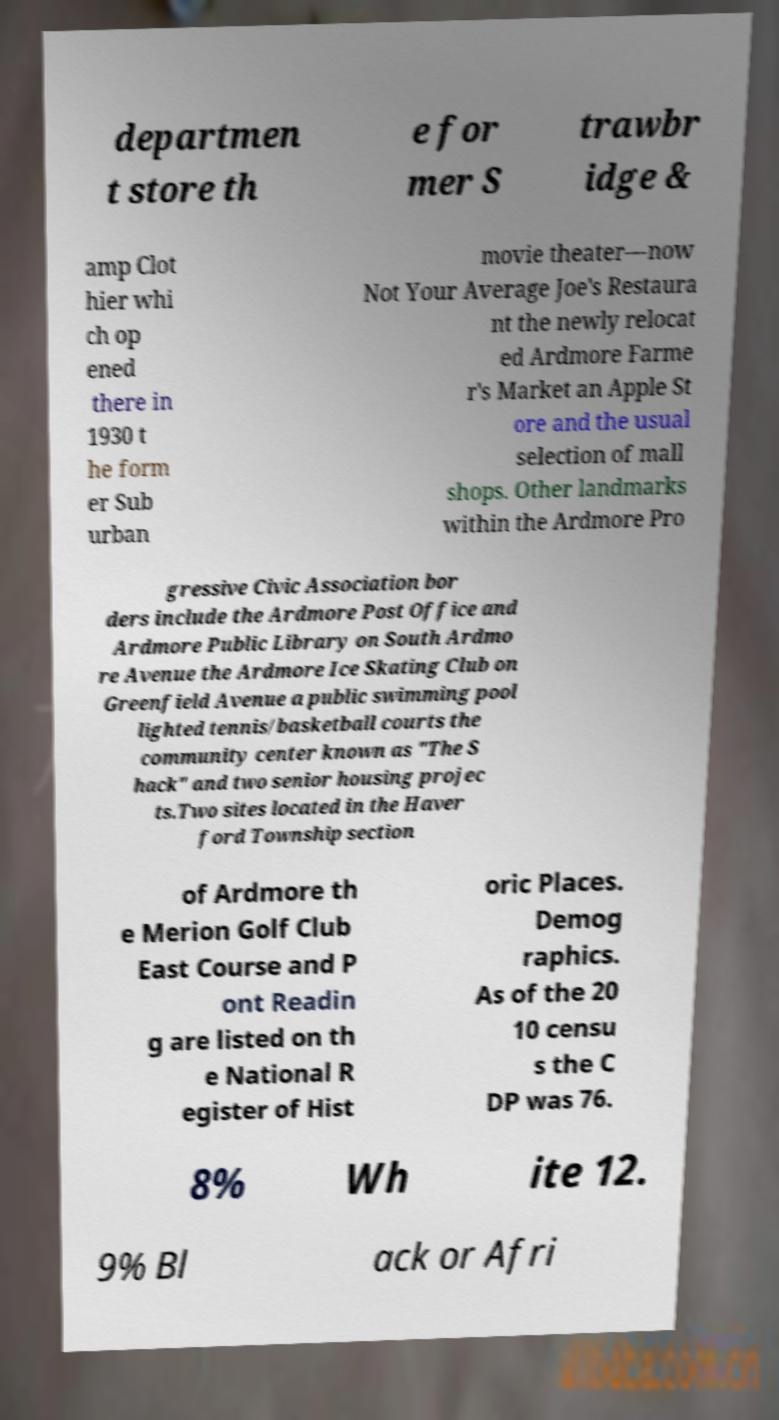There's text embedded in this image that I need extracted. Can you transcribe it verbatim? departmen t store th e for mer S trawbr idge & amp Clot hier whi ch op ened there in 1930 t he form er Sub urban movie theater—now Not Your Average Joe's Restaura nt the newly relocat ed Ardmore Farme r's Market an Apple St ore and the usual selection of mall shops. Other landmarks within the Ardmore Pro gressive Civic Association bor ders include the Ardmore Post Office and Ardmore Public Library on South Ardmo re Avenue the Ardmore Ice Skating Club on Greenfield Avenue a public swimming pool lighted tennis/basketball courts the community center known as "The S hack" and two senior housing projec ts.Two sites located in the Haver ford Township section of Ardmore th e Merion Golf Club East Course and P ont Readin g are listed on th e National R egister of Hist oric Places. Demog raphics. As of the 20 10 censu s the C DP was 76. 8% Wh ite 12. 9% Bl ack or Afri 